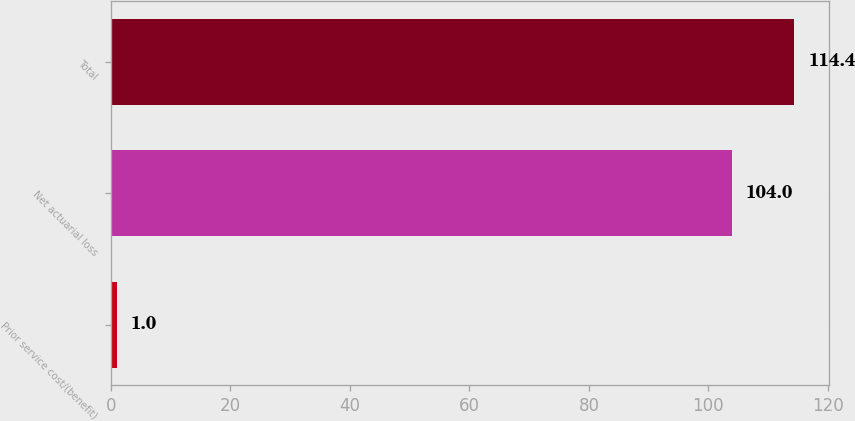<chart> <loc_0><loc_0><loc_500><loc_500><bar_chart><fcel>Prior service cost/(benefit)<fcel>Net actuarial loss<fcel>Total<nl><fcel>1<fcel>104<fcel>114.4<nl></chart> 